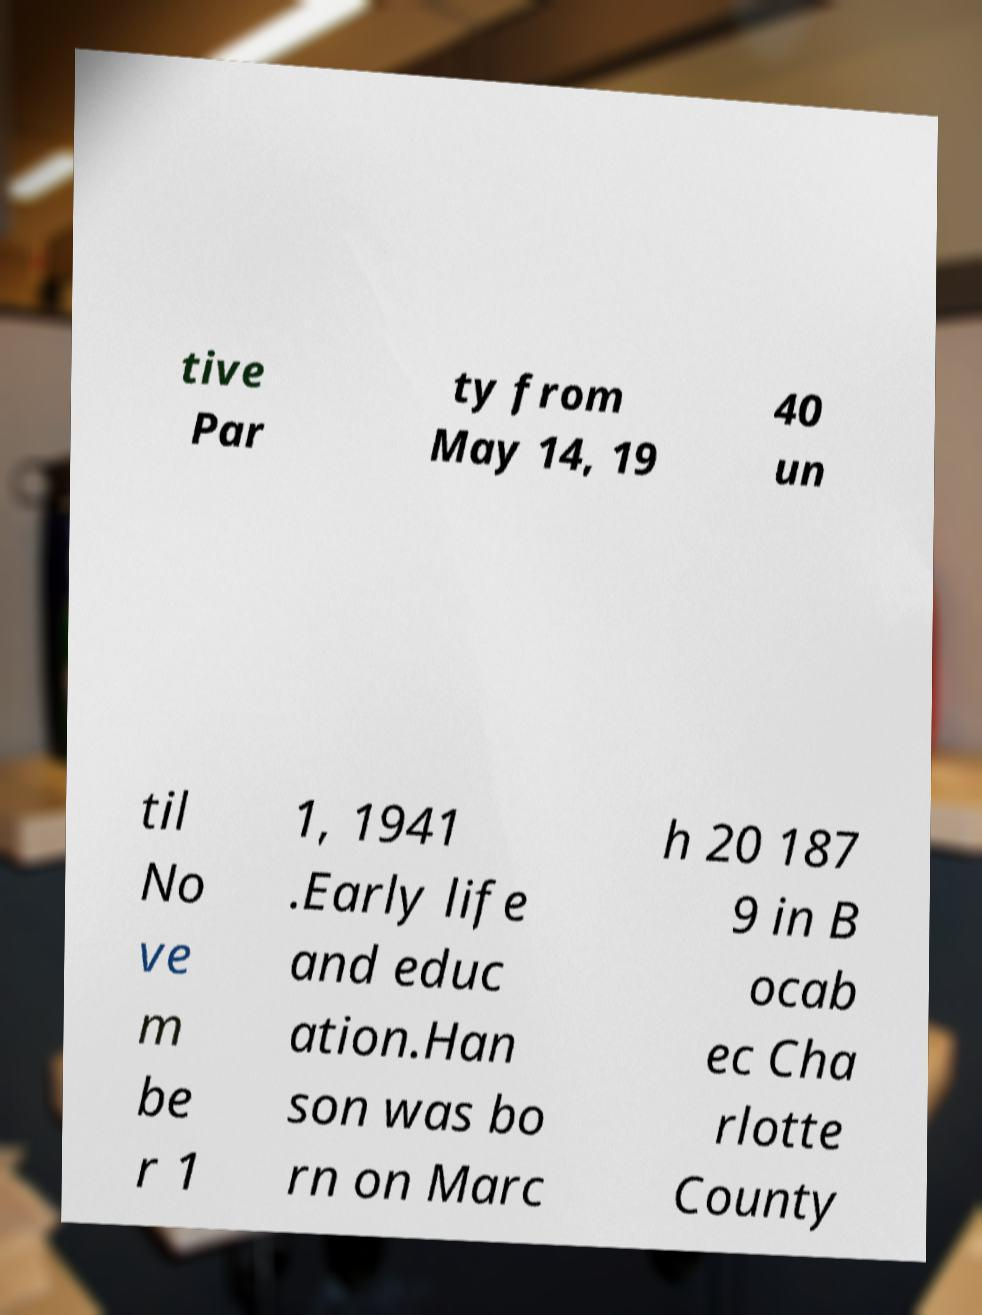Can you read and provide the text displayed in the image?This photo seems to have some interesting text. Can you extract and type it out for me? tive Par ty from May 14, 19 40 un til No ve m be r 1 1, 1941 .Early life and educ ation.Han son was bo rn on Marc h 20 187 9 in B ocab ec Cha rlotte County 